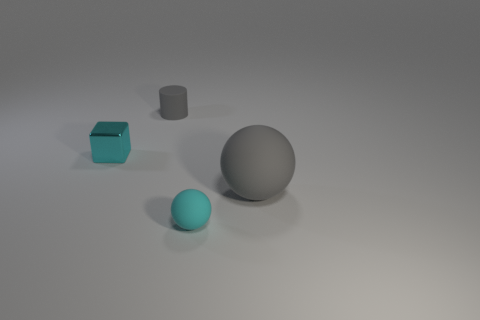Add 2 tiny yellow balls. How many objects exist? 6 Subtract all cylinders. How many objects are left? 3 Subtract 0 red cylinders. How many objects are left? 4 Subtract all gray objects. Subtract all big purple matte things. How many objects are left? 2 Add 3 large objects. How many large objects are left? 4 Add 2 small green spheres. How many small green spheres exist? 2 